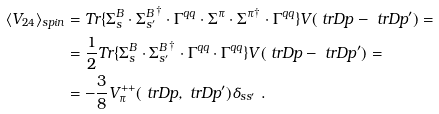<formula> <loc_0><loc_0><loc_500><loc_500>\langle V _ { 2 4 } \rangle _ { s p i n } & = T r \{ \Sigma ^ { B } _ { s } \cdot { \Sigma ^ { B } _ { s ^ { \prime } } } ^ { \dag } \cdot \Gamma ^ { q q } \cdot \Sigma ^ { \pi } \cdot { \Sigma ^ { \pi } } ^ { \dag } \cdot \Gamma ^ { q q } \} V ( \ t r D { p } - \ t r D { p } ^ { \prime } ) = \\ & = \frac { 1 } { 2 } T r \{ \Sigma ^ { B } _ { s } \cdot { \Sigma ^ { B } _ { s ^ { \prime } } } ^ { \dag } \cdot \Gamma ^ { q q } \cdot \Gamma ^ { q q } \} V ( \ t r D { p } - \ t r D { p } ^ { \prime } ) = \\ & = - \frac { 3 } { 8 } V _ { \pi } ^ { + + } ( \ t r D { p } , \ t r D { p } ^ { \prime } ) \delta _ { s s ^ { \prime } } \ .</formula> 